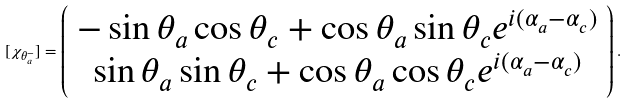<formula> <loc_0><loc_0><loc_500><loc_500>[ \chi _ { \theta _ { a } ^ { - } } ] = \left ( \begin{array} { c } - \sin \theta _ { a } \cos \theta _ { c } + \cos \theta _ { a } \sin \theta _ { c } e ^ { i ( \alpha _ { a } - \alpha _ { c } ) } \\ \sin \theta _ { a } \sin \theta _ { c } + \cos \theta _ { a } \cos \theta _ { c } e ^ { i ( \alpha _ { a } - \alpha _ { c } ) } \end{array} \right ) .</formula> 